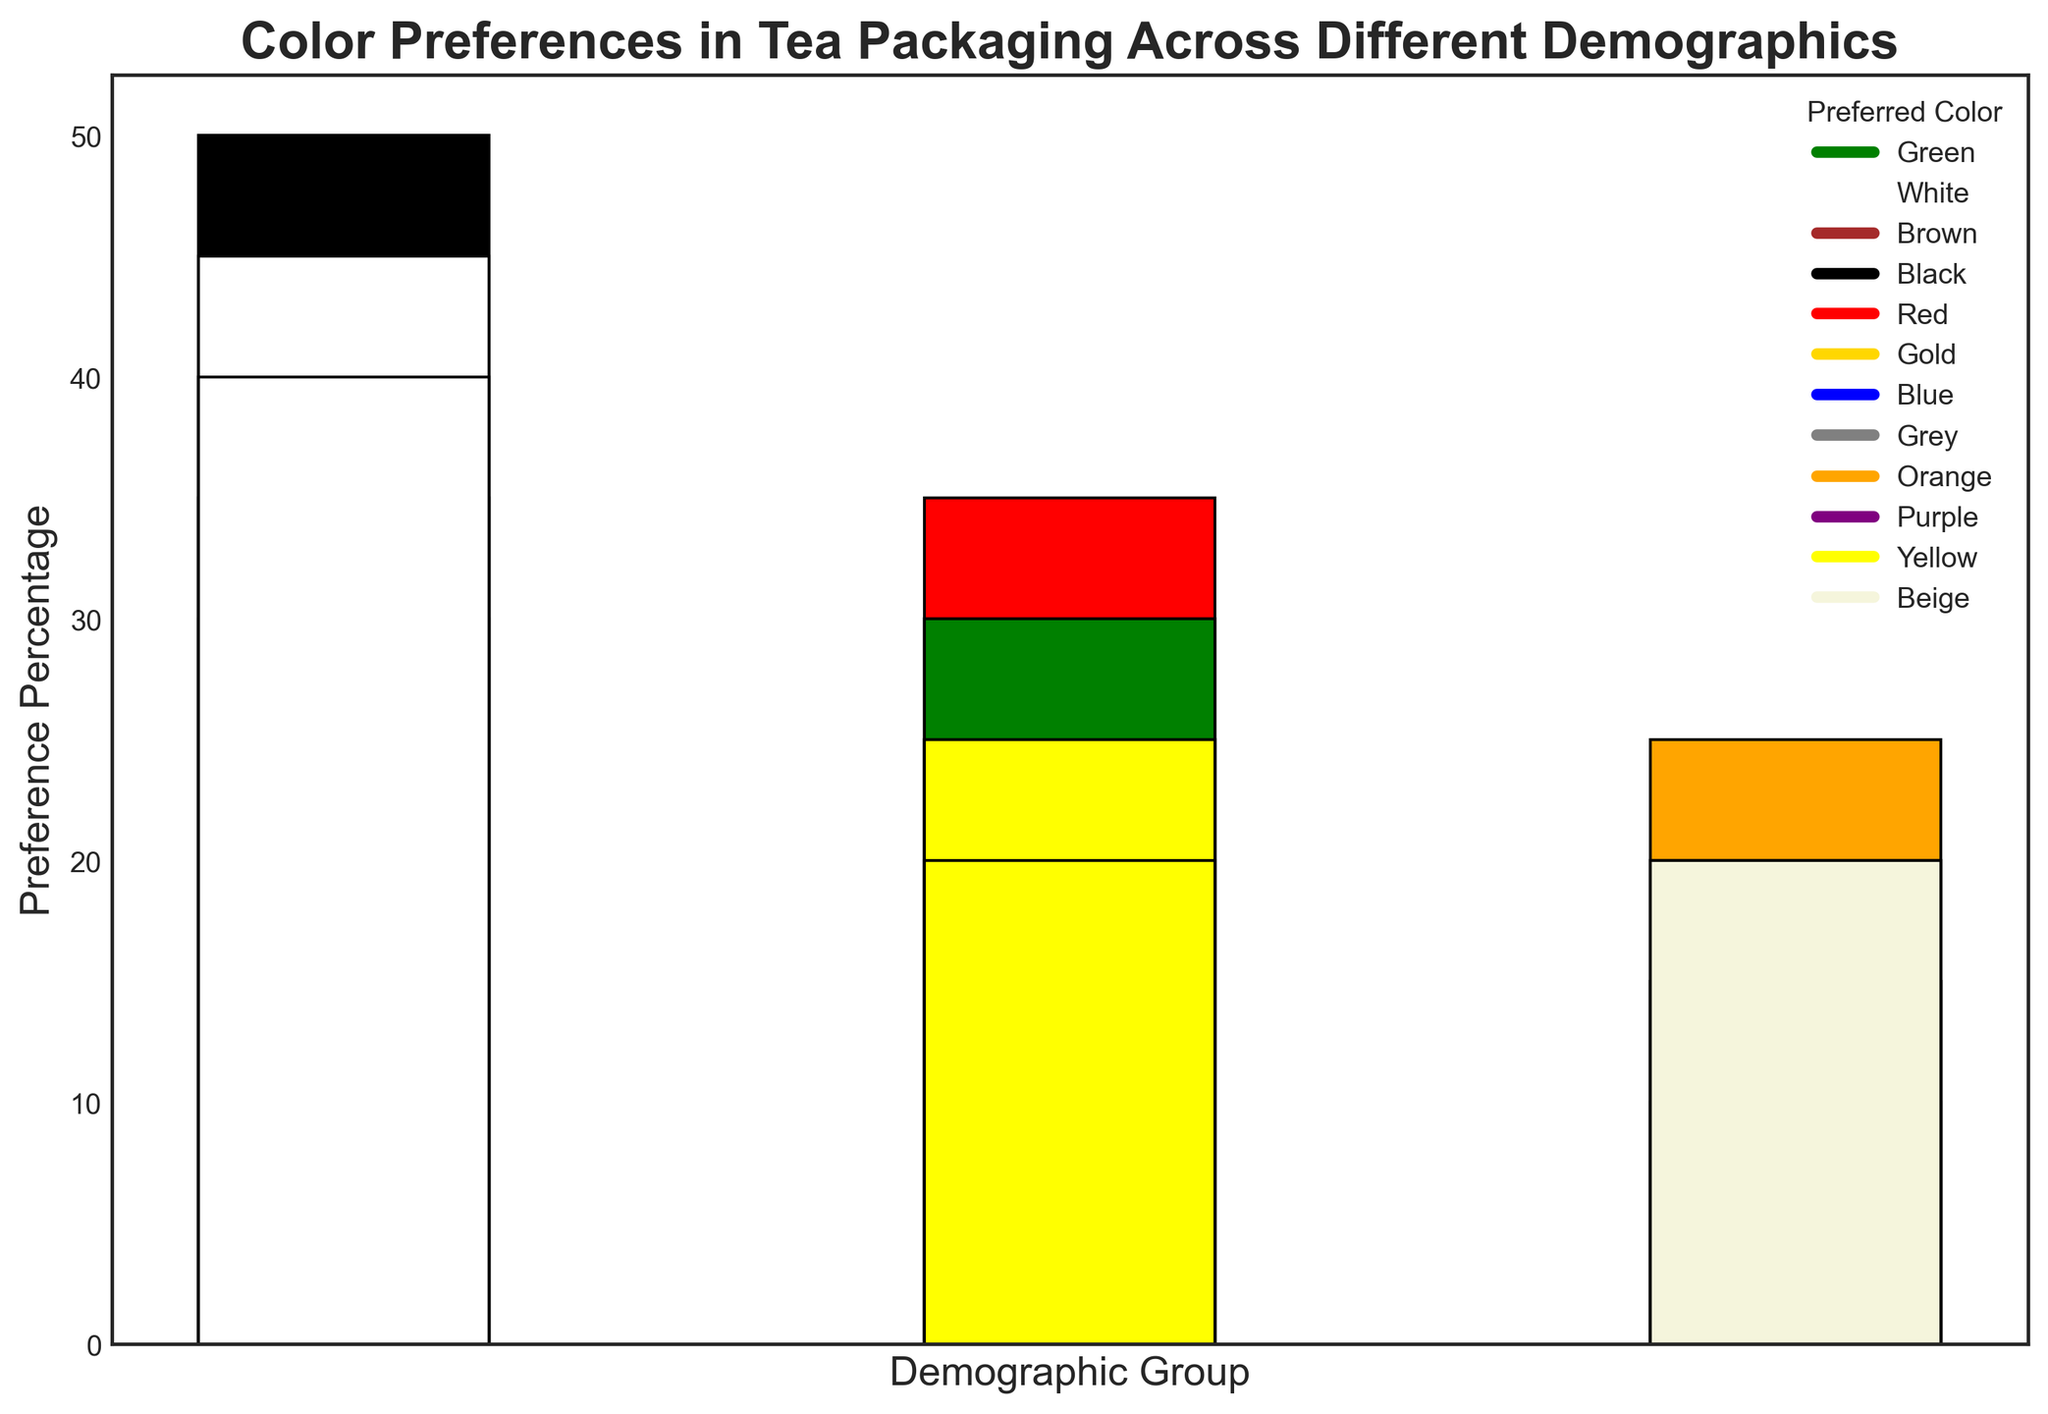What is the most preferred packaging color for Green Tea among males aged 18-25? Looking at the bar representing Green Tea preferences among 18-25-year-old males, we see that the tallest bar corresponds to the color Green. Therefore, Green is the most preferred color in this group.
Answer: Green Which gender over 60 prefers White as the packaging color for White Tea the most? Observing the White Tea preferences for individuals over 60, we notice that females have a taller bar for the color White compared to males. Hence, females prefer White more than males in this age group.
Answer: Female What is the least preferred packaging color for Herbal Tea among females aged 46-60? For the demographic group of females aged 46-60 and Herbal Tea preferences, the shortest bar represents the color Blue. This indicates that Blue is the least preferred color.
Answer: Blue Compare the preference percentages for the color Purple in Herbal Tea packaging between males and females aged 46-60. Which group has a higher preference percentage? Observing the bars for Purple in Herbal Tea among the 46-60 age group, females have a taller bar compared to males, suggesting they have a higher preference percentage for the color Purple.
Answer: Females What is the most preferred color for Black Tea among females aged 26-35? For Black Tea preferences among females aged 26-35, the tallest bar represents the color Black. Thus, Black is the most preferred color in this group.
Answer: Black Calculate the total preference percentage for the color Yellow across all demographics. Summing up the preference percentages for the color Yellow in all relevant bars: 20 (Male >60, White Tea) + 25 (Female >60, White Tea) = 45%.
Answer: 45% What color has the highest preference percentage for Oolong Tea among males aged 36-45? For Oolong Tea preferences among males aged 36-45, the tallest bar is the color Blue, indicating it has the highest preference percentage.
Answer: Blue Visualize and compare the heights of the bars for the color Blue across all age groups for males. Which age group shows the highest preference for Blue? Checking the heights of the Blue color bars across all age groups for males: the 36-45 group for Oolong Tea has a notable height compared to 46-60 for Herbal Tea and other groups. The 36-45 age group has the highest preference for Blue.
Answer: 36-45 What is the preferred packaging color for White Tea among males over 60 and how does it compare to females? Observing the preference for White Tea among males over 60, the tallest bar represents the color White. Females over 60 also prefer White the most, but the bar is slightly taller for females indicating a stronger preference.
Answer: White, Females > Males 